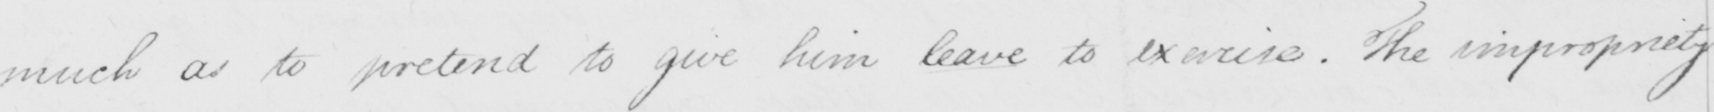Transcribe the text shown in this historical manuscript line. much as to pretend to give him leave to exercise . The impropriety 